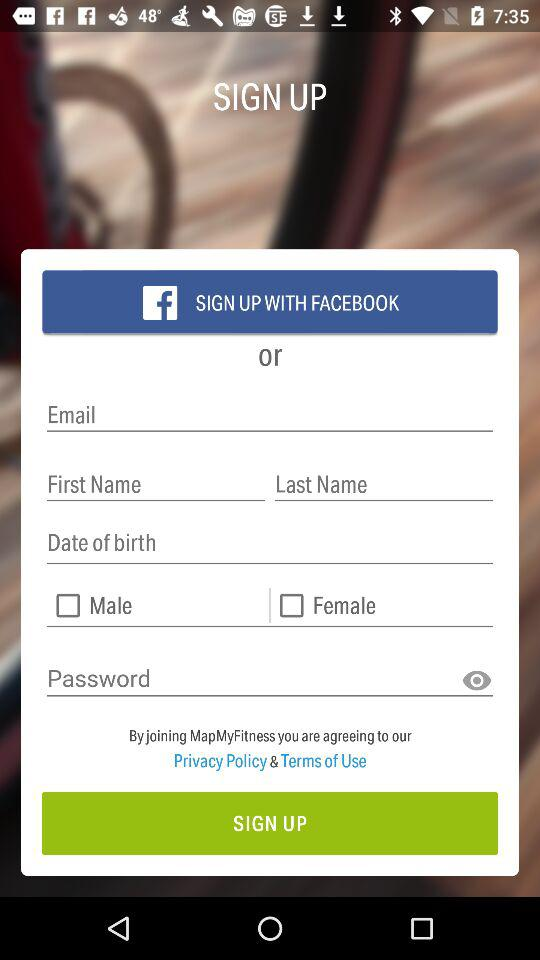How many checkbox labels are there for gender?
Answer the question using a single word or phrase. 2 